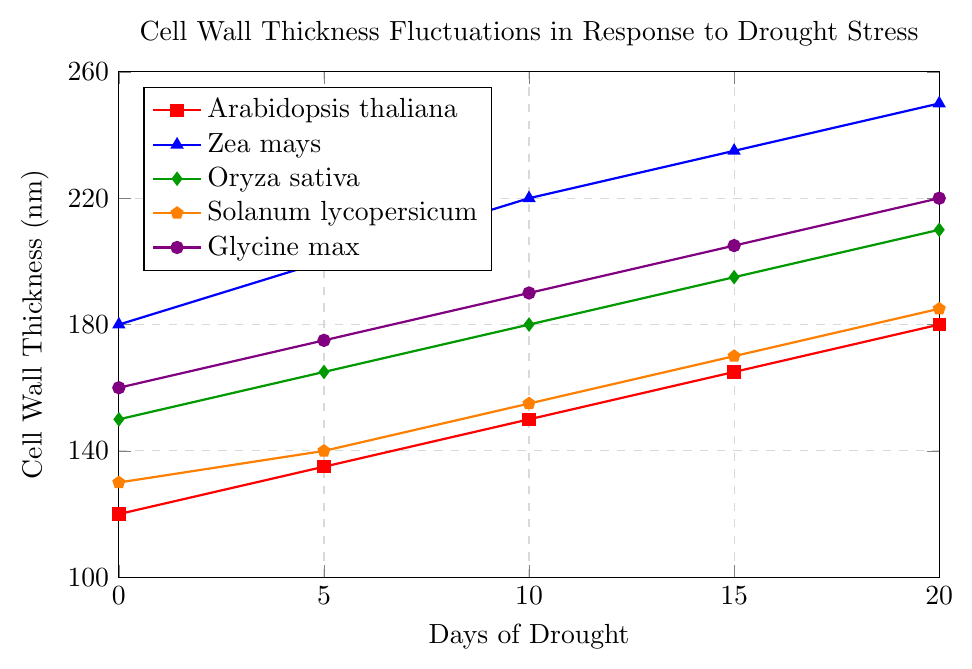Which plant variety has the highest cell wall thickness at 10 days of drought? Zea mays shows the highest cell wall thickness at 10 days, with a value of 220 nm. This is determined by inspecting each line at the 10-day mark and finding the highest thickness.
Answer: Zea mays What is the percentage increase in cell wall thickness for Arabidopsis thaliana from 0 to 20 days of drought? The thickness increases from 120 nm to 180 nm. The percentage increase is calculated as ((180 - 120) / 120) * 100% = 50%.
Answer: 50% Which plant variety shows the smallest change in cell wall thickness from 0 to 20 days of drought? Solanum lycopersicum changes from 130 nm to 185 nm, which is a difference of 55 nm. All other varieties show larger changes.
Answer: Solanum lycopersicum Which plant variety showed the fastest initial increase in cell wall thickness within the first 5 days? By examining the lines' slopes between 0 and 5 days, Zea mays increases from 180 to 200 nm, which is a rise of 20 nm, the highest among the varieties.
Answer: Zea mays Which plant varieties have a similar cell wall thickness after 5 days of drought? After 5 days, Arabidopsis thaliana is at 135 nm and Solanum lycopersicum is at 140 nm, both showing similar thickness values.
Answer: Arabidopsis thaliana and Solanum lycopersicum What is the average cell wall thickness across all plant varieties at 20 days of drought? Adding the thicknesses at 20 days (180 + 250 + 210 + 185 + 220) and dividing by 5 gives the average: (180 + 250 + 210 + 185 + 220) / 5 = 1045 / 5 = 209.
Answer: 209 Which plant variety has a continuous linear growth in cell wall thickness over the 20 days? Arabidopsis thaliana shows a consistent linear growth with a thickness increase of 15 nm every 5 days. This can be inferred from the uniform slope of its line plot.
Answer: Arabidopsis thaliana How does the cell wall thickness of Glycine max at 15 days of drought compare to that of Oryza sativa? At 15 days, Glycine max has a thickness of 205 nm, while Oryza sativa has 195 nm. Glycine max's cell wall is 10 nm thicker than Oryza sativa's.
Answer: Glycine max is 10 nm thicker What is the difference in cell wall thickness between Zea mays and Oryza sativa at the beginning of the drought? At 0 days, Zea mays is at 180 nm and Oryza sativa is at 150 nm, making the difference 180 - 150 = 30 nm.
Answer: 30 nm How much thicker does the cell wall of Oryza sativa become from 5 to 20 days of drought? From 5 days (165 nm) to 20 days (210 nm), the increase in cell wall thickness is 210 - 165 = 45 nm.
Answer: 45 nm 